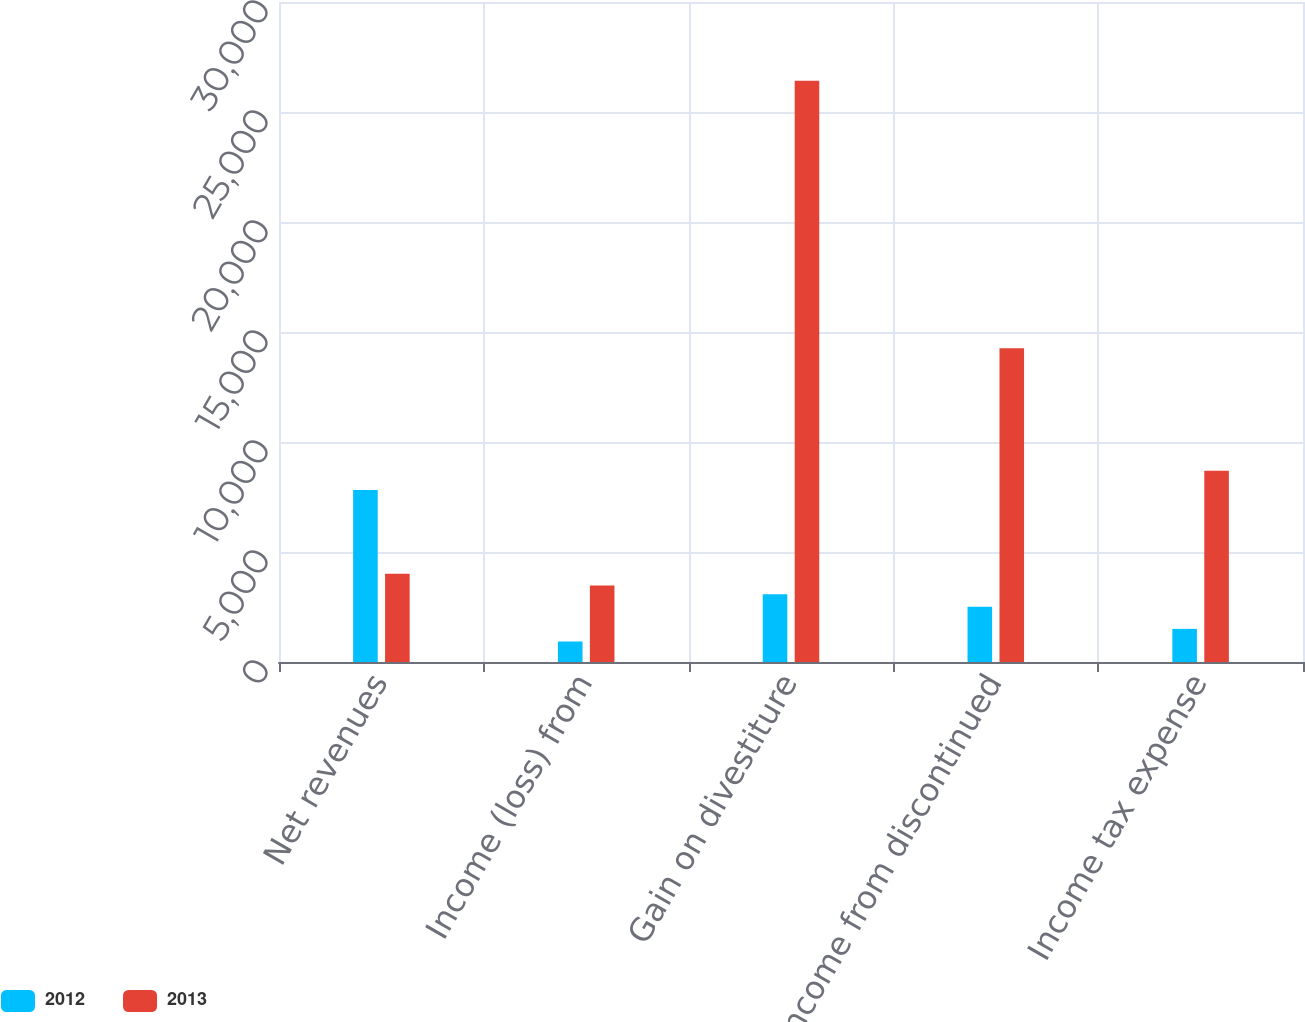Convert chart to OTSL. <chart><loc_0><loc_0><loc_500><loc_500><stacked_bar_chart><ecel><fcel>Net revenues<fcel>Income (loss) from<fcel>Gain on divestiture<fcel>Income from discontinued<fcel>Income tax expense<nl><fcel>2012<fcel>7813<fcel>932<fcel>3080<fcel>2506<fcel>1506<nl><fcel>2013<fcel>4012<fcel>3472<fcel>26419<fcel>14259<fcel>8688<nl></chart> 